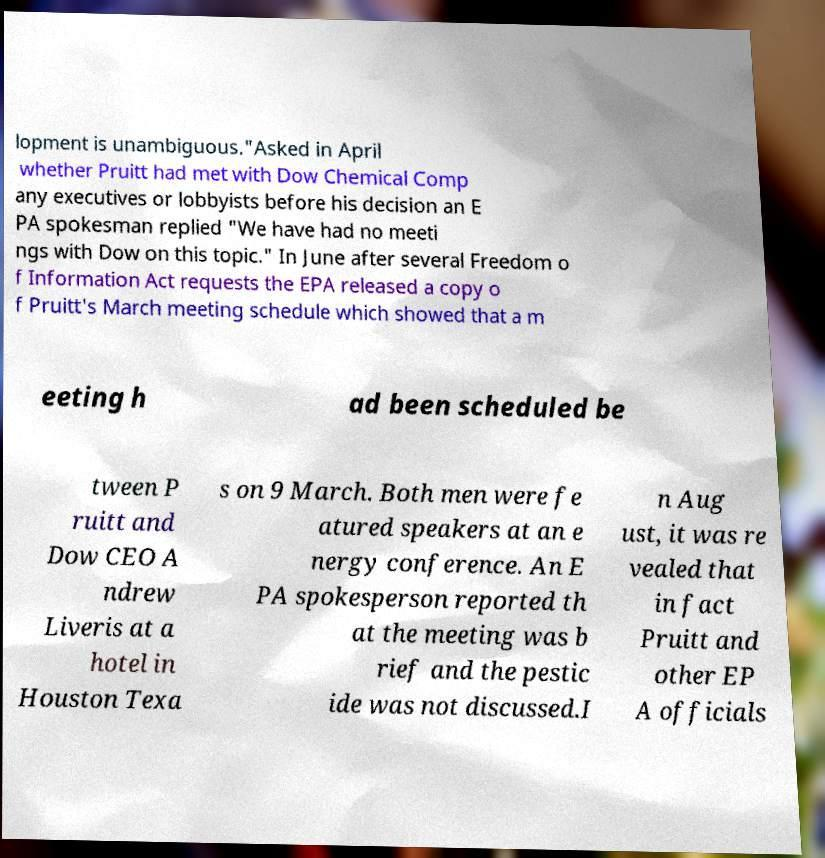Please read and relay the text visible in this image. What does it say? lopment is unambiguous."Asked in April whether Pruitt had met with Dow Chemical Comp any executives or lobbyists before his decision an E PA spokesman replied "We have had no meeti ngs with Dow on this topic." In June after several Freedom o f Information Act requests the EPA released a copy o f Pruitt's March meeting schedule which showed that a m eeting h ad been scheduled be tween P ruitt and Dow CEO A ndrew Liveris at a hotel in Houston Texa s on 9 March. Both men were fe atured speakers at an e nergy conference. An E PA spokesperson reported th at the meeting was b rief and the pestic ide was not discussed.I n Aug ust, it was re vealed that in fact Pruitt and other EP A officials 